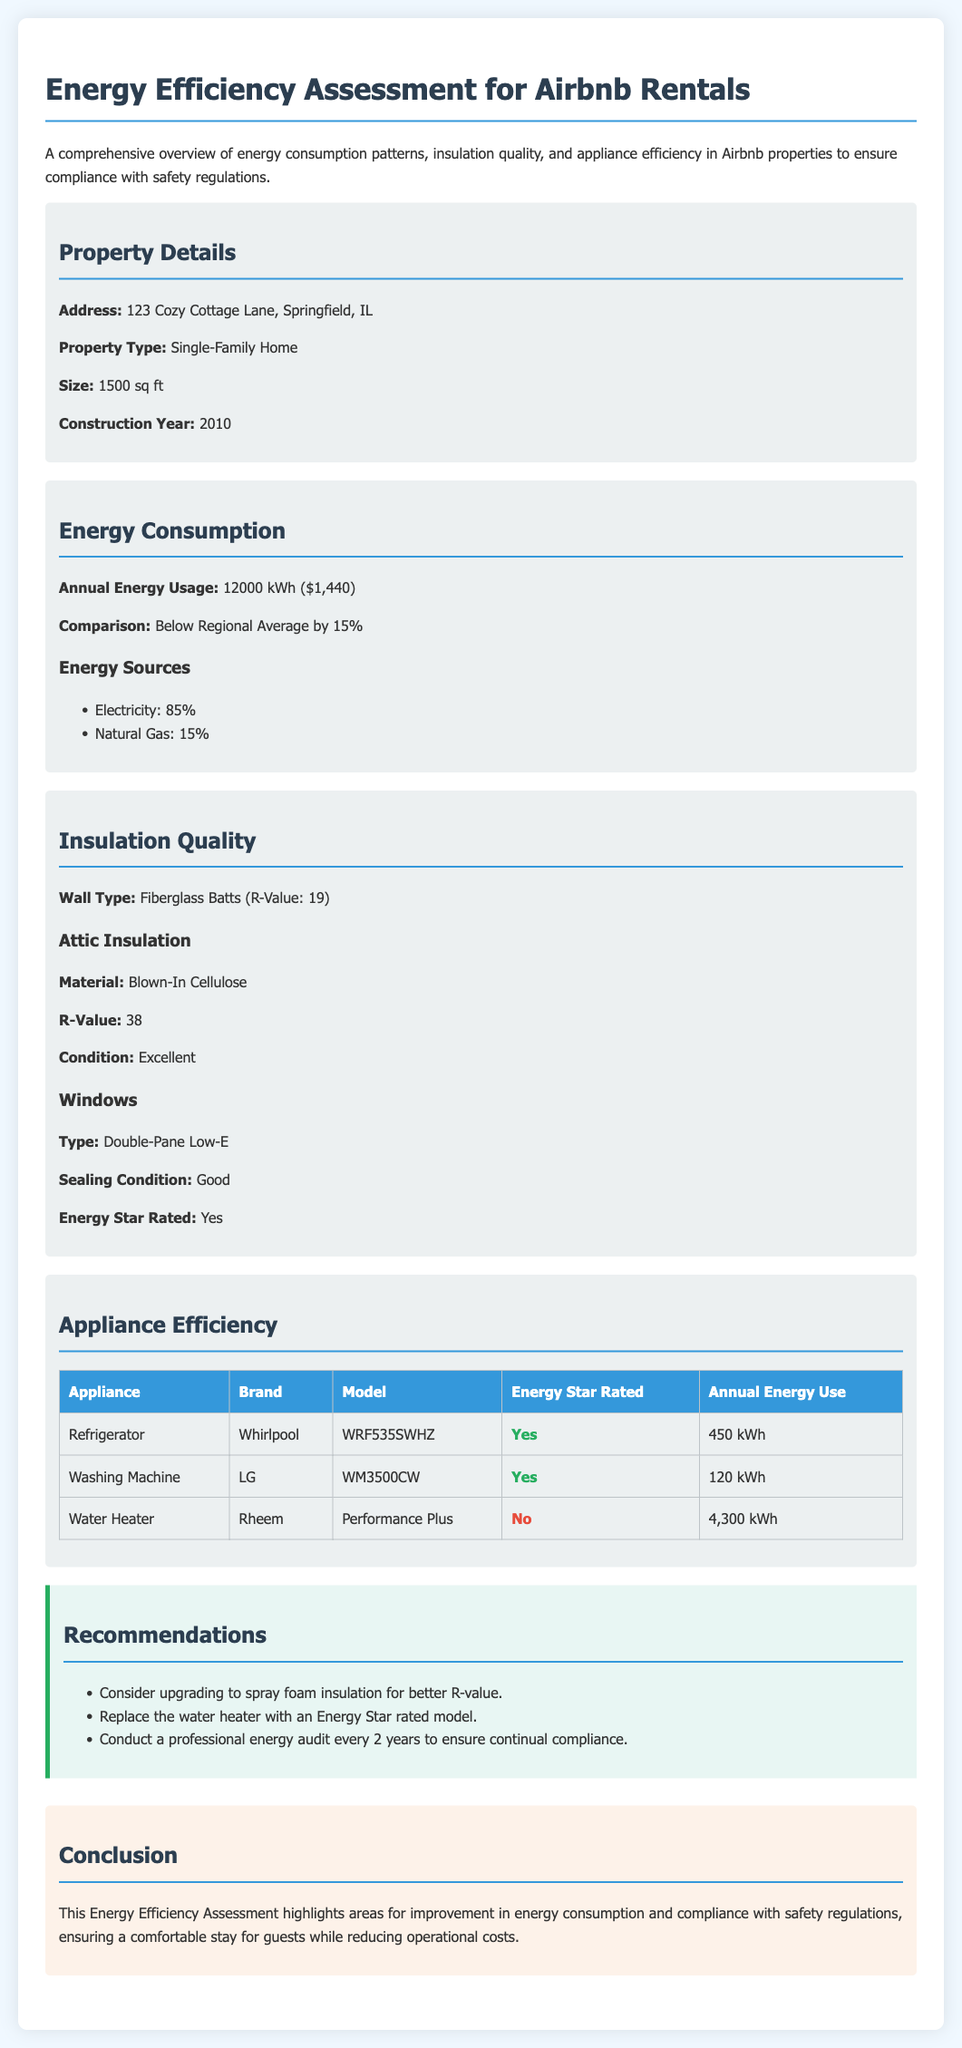What is the address of the property? The address is provided in the property details section of the document.
Answer: 123 Cozy Cottage Lane, Springfield, IL What is the annual energy usage? The document specifies the annual energy usage in the energy consumption section.
Answer: 12000 kWh What type of insulation is used for the walls? The wall type is listed under the insulation quality section of the document.
Answer: Fiberglass Batts What is the R-Value of the attic insulation? The R-Value for attic insulation is mentioned under the insulation quality section.
Answer: 38 How much annual energy does the washing machine use? The annual energy use of the washing machine is detailed in the appliance efficiency table.
Answer: 120 kWh Is the refrigerator Energy Star rated? The energy efficiency rating of the refrigerator is addressed in the appliance efficiency table.
Answer: Yes What is the main recommendation related to the water heater? The recommendations section mentions specific suggestions for improvements in energy efficiency.
Answer: Replace the water heater with an Energy Star rated model What percentage of the energy sources is electricity? The breakdown of energy sources is included in the energy consumption section.
Answer: 85% What type of windows does the property have? Information about the windows is given under the insulation quality section of the document.
Answer: Double-Pane Low-E 